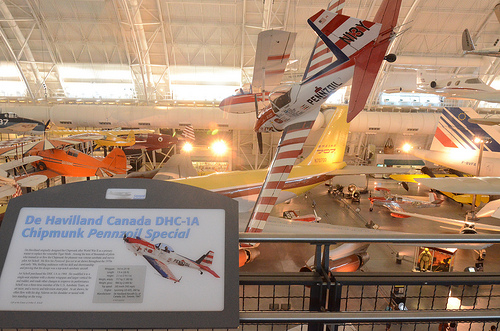<image>
Can you confirm if the plane is behind the fence? Yes. From this viewpoint, the plane is positioned behind the fence, with the fence partially or fully occluding the plane. 